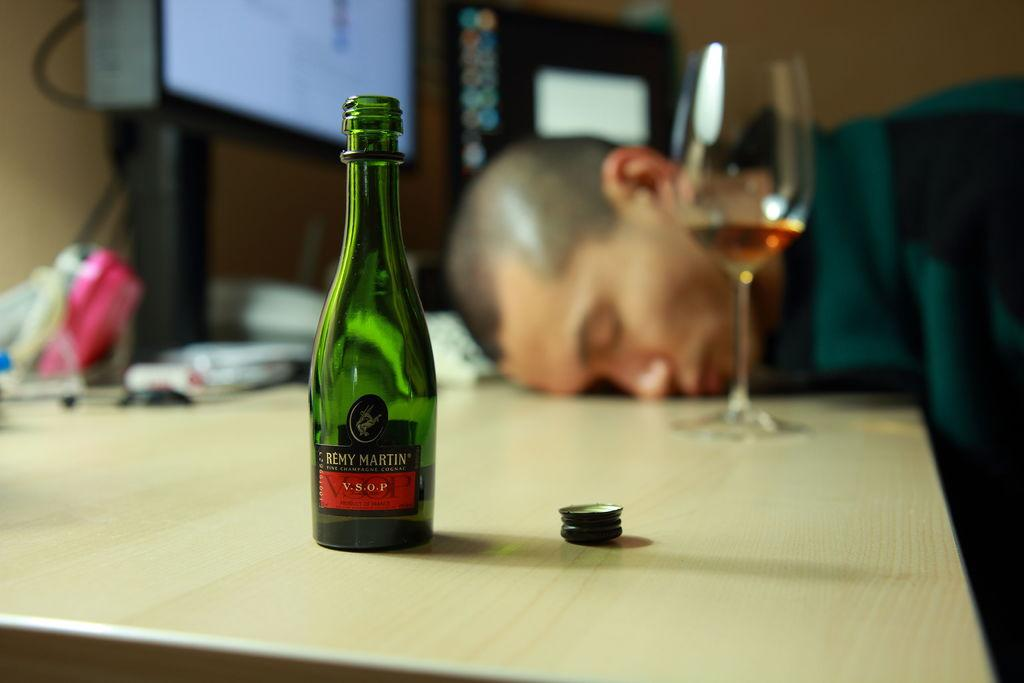What object can be seen in the image that might contain a liquid? There is a bottle in the image that might contain a liquid. What is covering the opening of the bottle? There is a lid in the image that is covering the opening of the bottle. Where are the bottle and lid located? Both the bottle and lid are on a table. What is the position of the person in the image? There is a guy leaning on the table. What other object is present on the table? There is a glass on the table. What type of organization is the guy representing in the image? There is no indication in the image that the guy is representing any organization. What is the guy's reaction to the shocking news in the image? There is no indication in the image that any shocking news has been received or that the guy is reacting to it. 